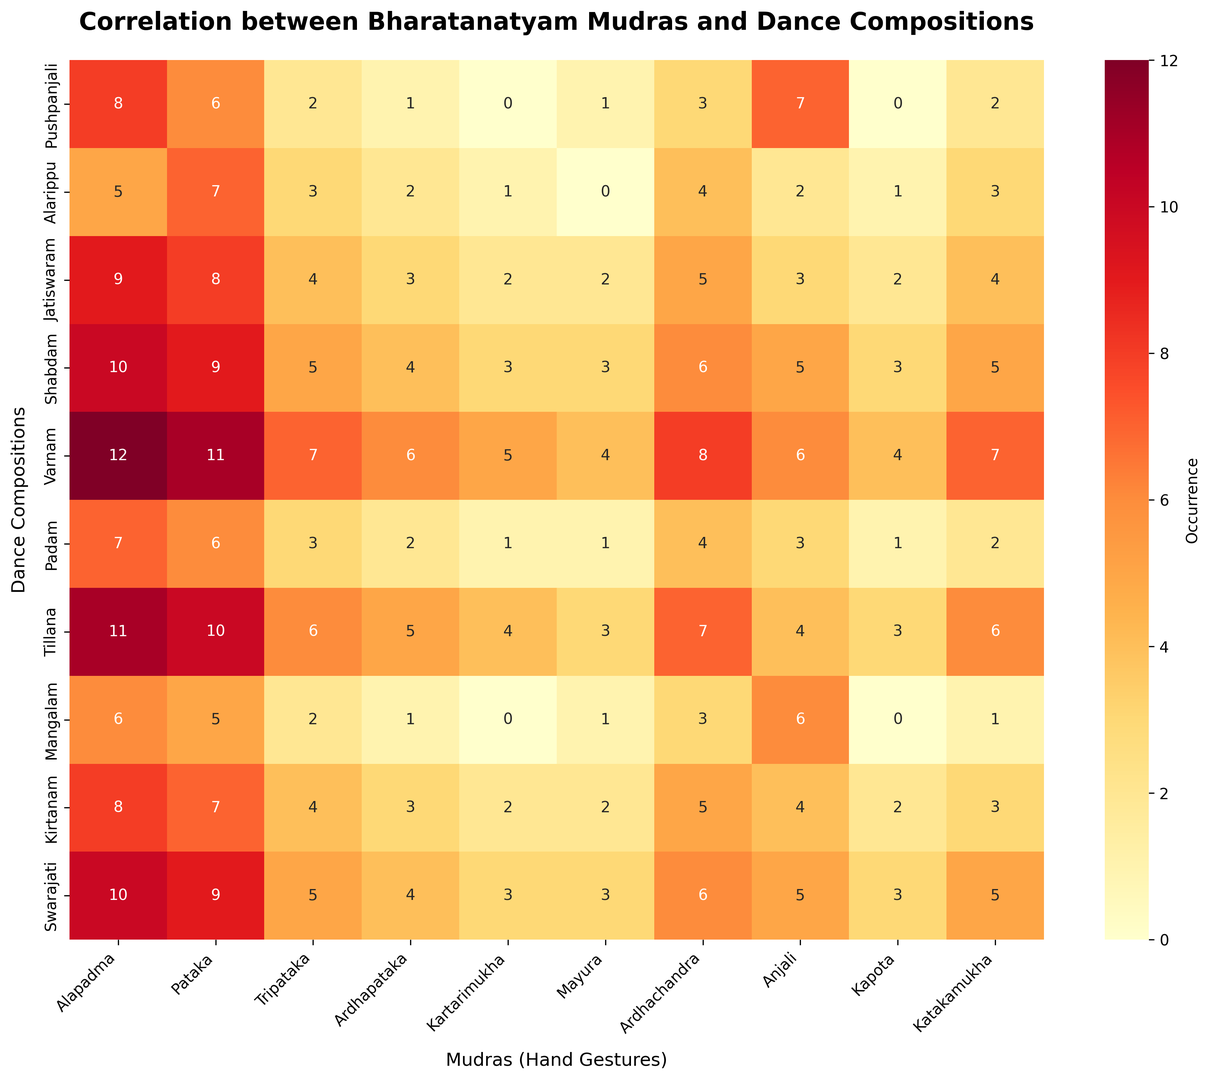what is the most frequently occurring mudra across all compositions? To answer this, look at the columns in the heatmap to see which one has the highest sum of values. Add up all occurrences for each mudra: Alapadma (8+5+9+10+12+7+11+6+8+10 = 86), Pataka (6+7+8+9+11+6+10+5+7+9 = 78), and so on. The mudra with the highest value is the most frequent.
Answer: Alapadma which composition has the highest usage of 'Katakamukha' mudra? Check the 'Katakamukha' column and identify the highest value. Match this highest value with its corresponding composition on the y-axis. Here, the values in 'Katakamukha' are (2, 3, 4, 5, 7, 2, 6, 1, 3, 5). The highest value is 7, corresponding to 'Varnam'.
Answer: Varnam considering 'Pushpanjali' and 'Alarippu' compositions, which mudra is equally used in both? Compare the values for each mudra in 'Pushpanjali' and 'Alarippu' rows. Match the values and identify mudra(s) that have the same occurrence in both compositions. In this case, there is no mudra used equally in both compositions.
Answer: None what is the average occurrence of the 'Mayura' mudra across all compositions? To find the average, sum all the occurrences of 'Mayura' mudra and then divide by the number of compositions. Sum is 1+0+2+3+4+1+3+1+2+3 = 20, and the number of compositions is 10. Therefore, the average is 20/10.
Answer: 2 which dance composition uses the widest variety of mudras? Determine the variety by counting non-zero entries for each composition. The composition with the maximum non-zero values uses the widest variety of mudras. For example, 'Alapadma' has 9 non-zero entries.
Answer: Varnam which two compositions have the closest total mudra usage? Sum the occurrences of all mudras for each composition and compare the totals to find the closest values. (Pushpanjali=30, Alarippu=28, Jatiswaram=42, Shabdam=53, Varnam=70, Padam=28, Tillana=55, Mangalam=25, Kirtanam=38, Swamajari=51). 'Alarippu' and 'Padam' both have 28.
Answer: Alarippu and Padam which mudra is used least often in 'Tillana'? Check the row for 'Tillana' and identify the lowest value other than zero. Values for 'Tillana' are (11, 10, 6, 5, 4, 3, 7, 4, 3, 6). The smallest non-zero value is 3 for 'Pataka'.
Answer: Pataka 